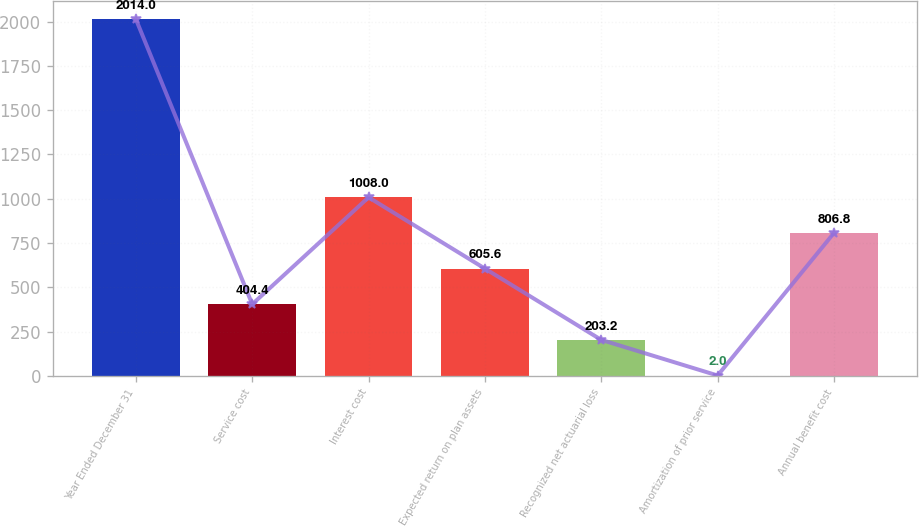<chart> <loc_0><loc_0><loc_500><loc_500><bar_chart><fcel>Year Ended December 31<fcel>Service cost<fcel>Interest cost<fcel>Expected return on plan assets<fcel>Recognized net actuarial loss<fcel>Amortization of prior service<fcel>Annual benefit cost<nl><fcel>2014<fcel>404.4<fcel>1008<fcel>605.6<fcel>203.2<fcel>2<fcel>806.8<nl></chart> 